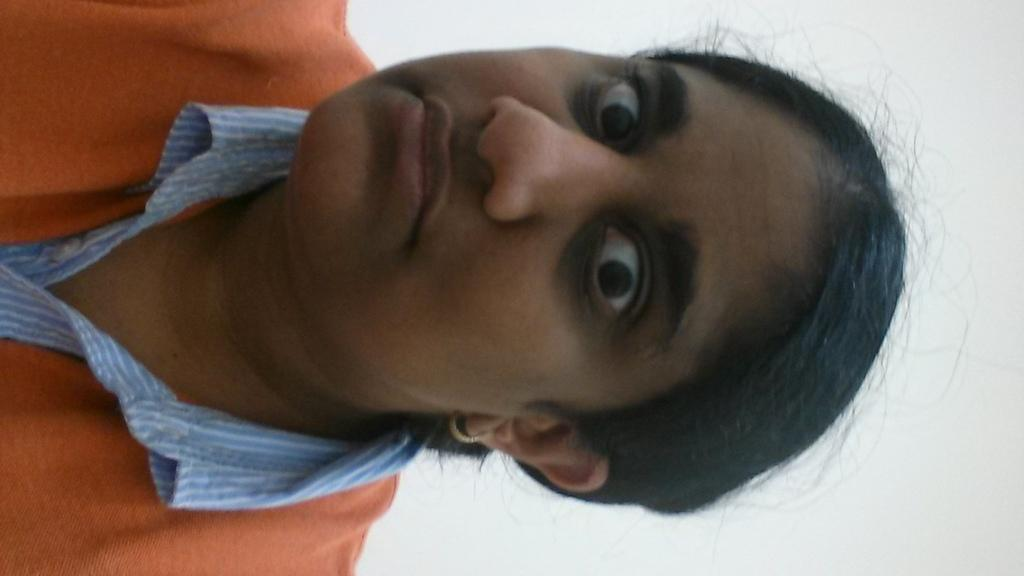Who is the main subject in the image? There is a girl in the image. What is the girl wearing? The girl is wearing a dress with white, blue, and orange colors. What color is the background of the image? The background of the image is white. What is the governor's opinion on the girl's dress in the image? There is no information about the governor or their opinion in the image. 